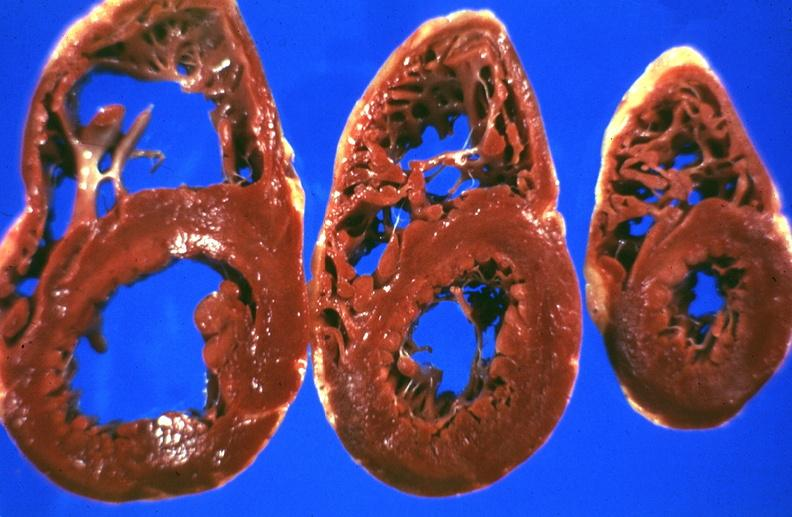s jejunum present?
Answer the question using a single word or phrase. No 